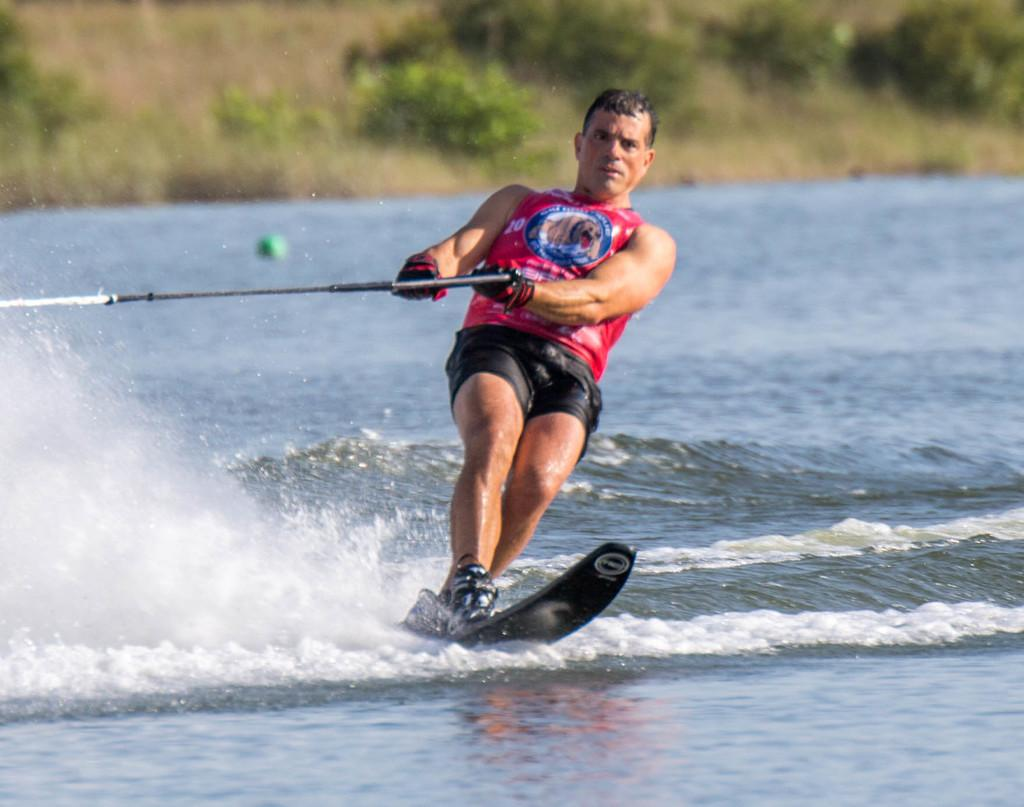What activity is the man in the image engaged in? The man is wakeboarding on the water. What other object can be seen in the image? There is a ball in the image. What type of terrain is visible in the image? There is grass in the image. What type of vegetation is present in the image? There is a group of plants in the image. What type of haircut does the bird in the image have? There is no bird present in the image, so it is not possible to determine the type of haircut it might have. 